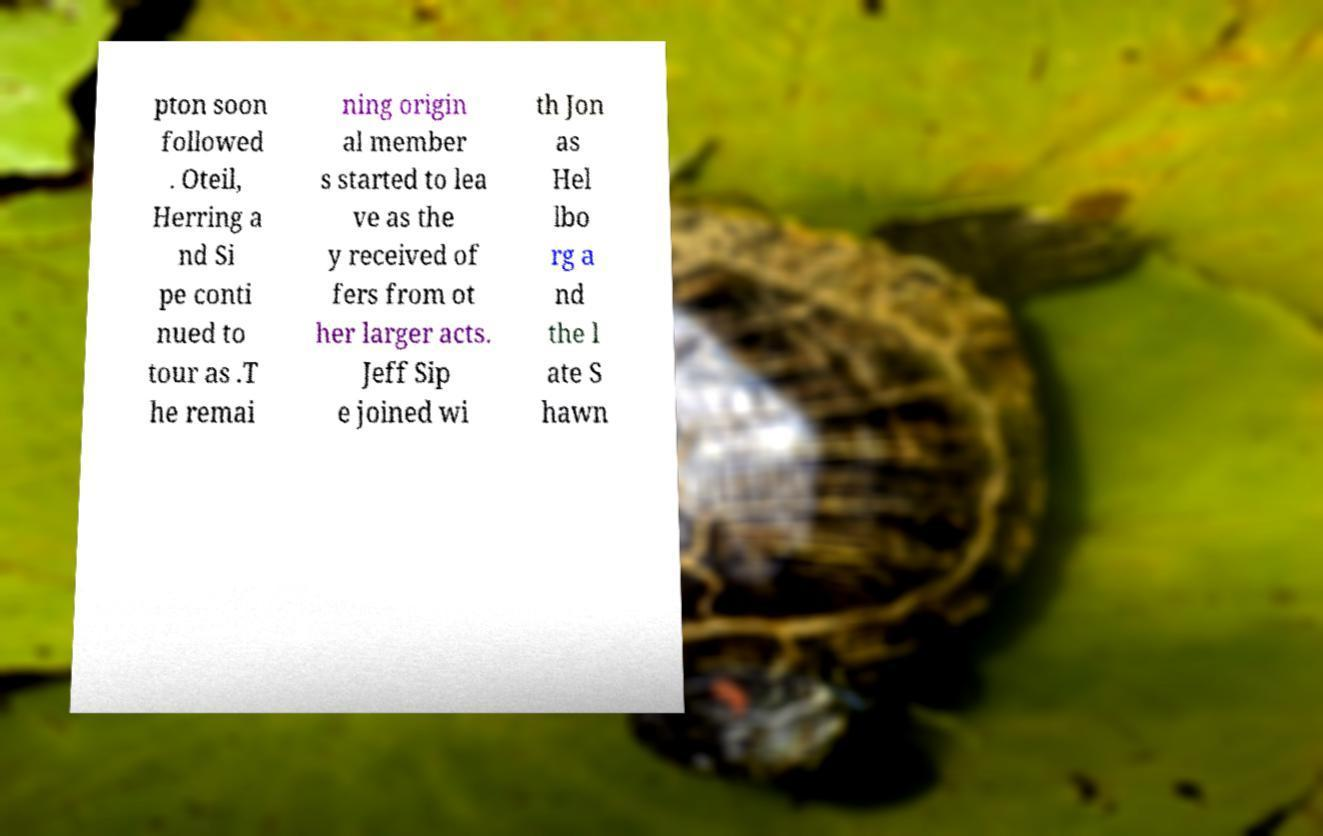I need the written content from this picture converted into text. Can you do that? pton soon followed . Oteil, Herring a nd Si pe conti nued to tour as .T he remai ning origin al member s started to lea ve as the y received of fers from ot her larger acts. Jeff Sip e joined wi th Jon as Hel lbo rg a nd the l ate S hawn 